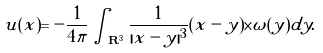Convert formula to latex. <formula><loc_0><loc_0><loc_500><loc_500>u ( x ) = - \frac { 1 } { 4 \pi } \int _ { { \mathbf R } ^ { 3 } } \frac { 1 } { | x - y | ^ { 3 } } ( x - y ) \times \omega ( y ) d y .</formula> 